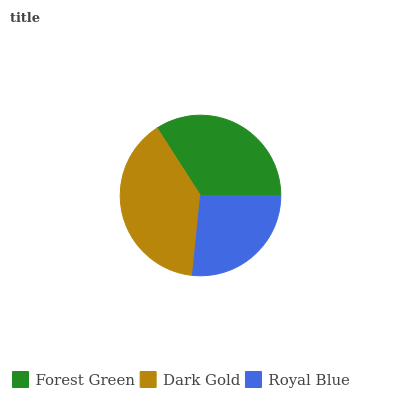Is Royal Blue the minimum?
Answer yes or no. Yes. Is Dark Gold the maximum?
Answer yes or no. Yes. Is Dark Gold the minimum?
Answer yes or no. No. Is Royal Blue the maximum?
Answer yes or no. No. Is Dark Gold greater than Royal Blue?
Answer yes or no. Yes. Is Royal Blue less than Dark Gold?
Answer yes or no. Yes. Is Royal Blue greater than Dark Gold?
Answer yes or no. No. Is Dark Gold less than Royal Blue?
Answer yes or no. No. Is Forest Green the high median?
Answer yes or no. Yes. Is Forest Green the low median?
Answer yes or no. Yes. Is Royal Blue the high median?
Answer yes or no. No. Is Royal Blue the low median?
Answer yes or no. No. 